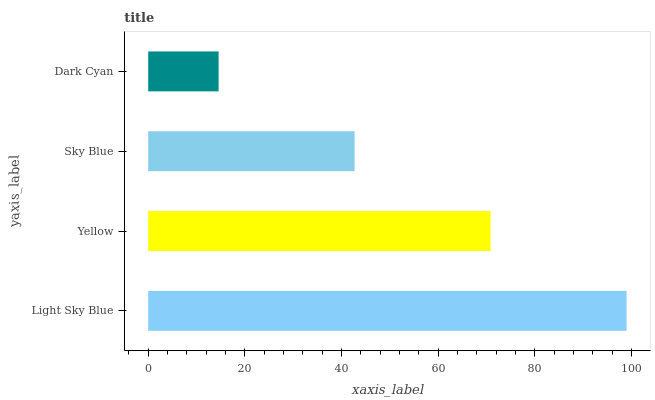Is Dark Cyan the minimum?
Answer yes or no. Yes. Is Light Sky Blue the maximum?
Answer yes or no. Yes. Is Yellow the minimum?
Answer yes or no. No. Is Yellow the maximum?
Answer yes or no. No. Is Light Sky Blue greater than Yellow?
Answer yes or no. Yes. Is Yellow less than Light Sky Blue?
Answer yes or no. Yes. Is Yellow greater than Light Sky Blue?
Answer yes or no. No. Is Light Sky Blue less than Yellow?
Answer yes or no. No. Is Yellow the high median?
Answer yes or no. Yes. Is Sky Blue the low median?
Answer yes or no. Yes. Is Sky Blue the high median?
Answer yes or no. No. Is Light Sky Blue the low median?
Answer yes or no. No. 